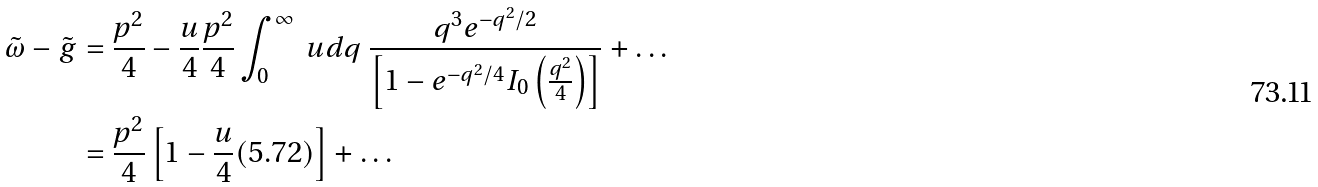Convert formula to latex. <formula><loc_0><loc_0><loc_500><loc_500>\tilde { \omega } - \tilde { g } & = \frac { p ^ { 2 } } { 4 } - \frac { u } { 4 } \frac { p ^ { 2 } } { 4 } \int ^ { \infty } _ { 0 } \ u d q \ \frac { q ^ { 3 } e ^ { - q ^ { 2 } / 2 } } { \left [ 1 - e ^ { - q ^ { 2 } / 4 } I _ { 0 } \left ( \frac { q ^ { 2 } } { 4 } \right ) \right ] } + \dots \\ & = \frac { p ^ { 2 } } { 4 } \left [ 1 - \frac { u } { 4 } ( 5 . 7 2 ) \right ] + \dots</formula> 